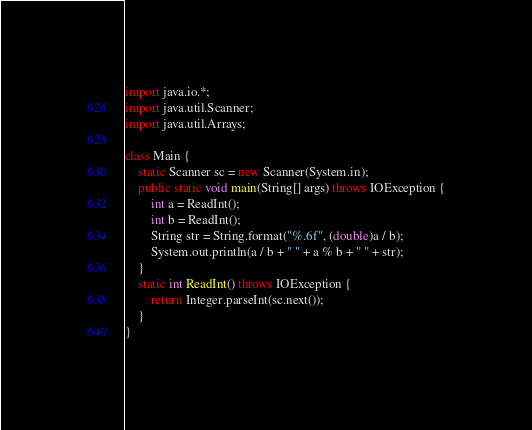Convert code to text. <code><loc_0><loc_0><loc_500><loc_500><_Java_>import java.io.*;
import java.util.Scanner;
import java.util.Arrays;

class Main {
    static Scanner sc = new Scanner(System.in);
    public static void main(String[] args) throws IOException {
        int a = ReadInt();
        int b = ReadInt();
        String str = String.format("%.6f", (double)a / b);
        System.out.println(a / b + " " + a % b + " " + str);
    }
    static int ReadInt() throws IOException {
        return Integer.parseInt(sc.next());
    }
}</code> 